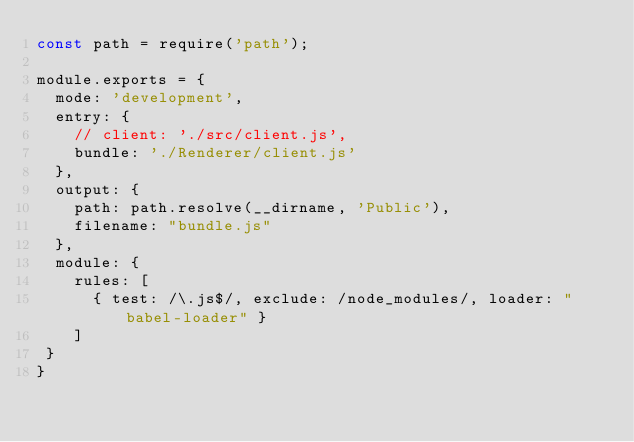Convert code to text. <code><loc_0><loc_0><loc_500><loc_500><_JavaScript_>const path = require('path');

module.exports = {
  mode: 'development',
  entry: {
    // client: './src/client.js',
    bundle: './Renderer/client.js'
  },
  output: {
    path: path.resolve(__dirname, 'Public'),
    filename: "bundle.js"
  },
  module: {
    rules: [
      { test: /\.js$/, exclude: /node_modules/, loader: "babel-loader" }
    ]
 }
}
</code> 